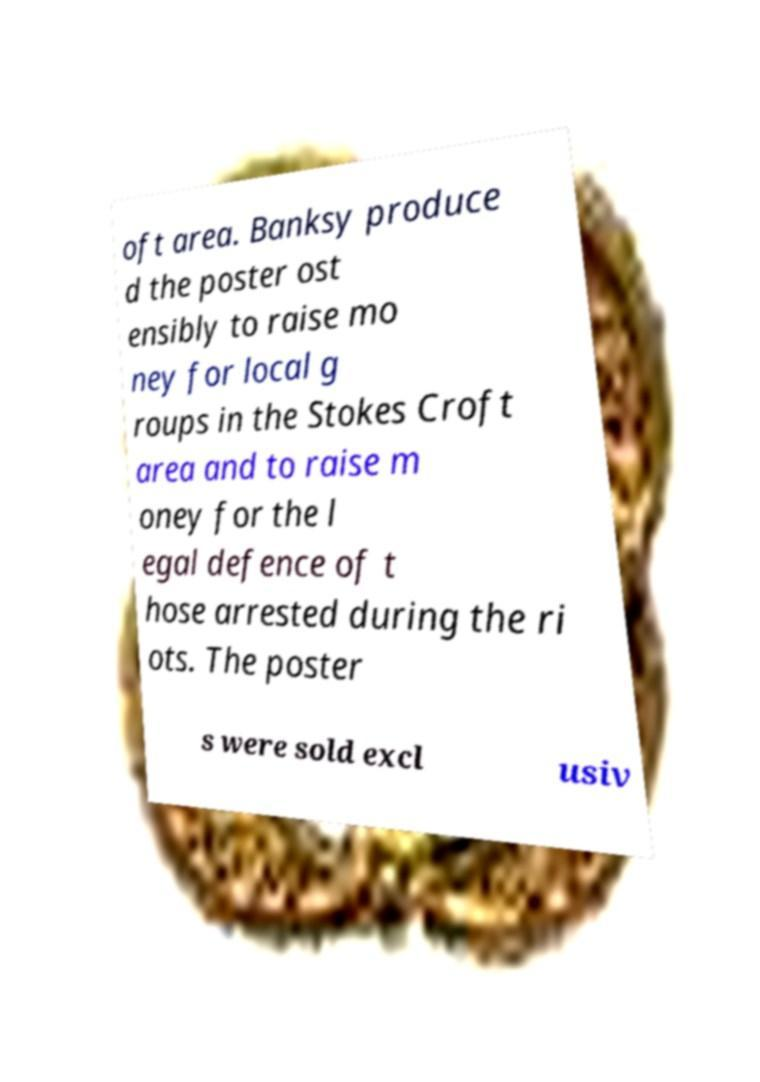Could you extract and type out the text from this image? oft area. Banksy produce d the poster ost ensibly to raise mo ney for local g roups in the Stokes Croft area and to raise m oney for the l egal defence of t hose arrested during the ri ots. The poster s were sold excl usiv 